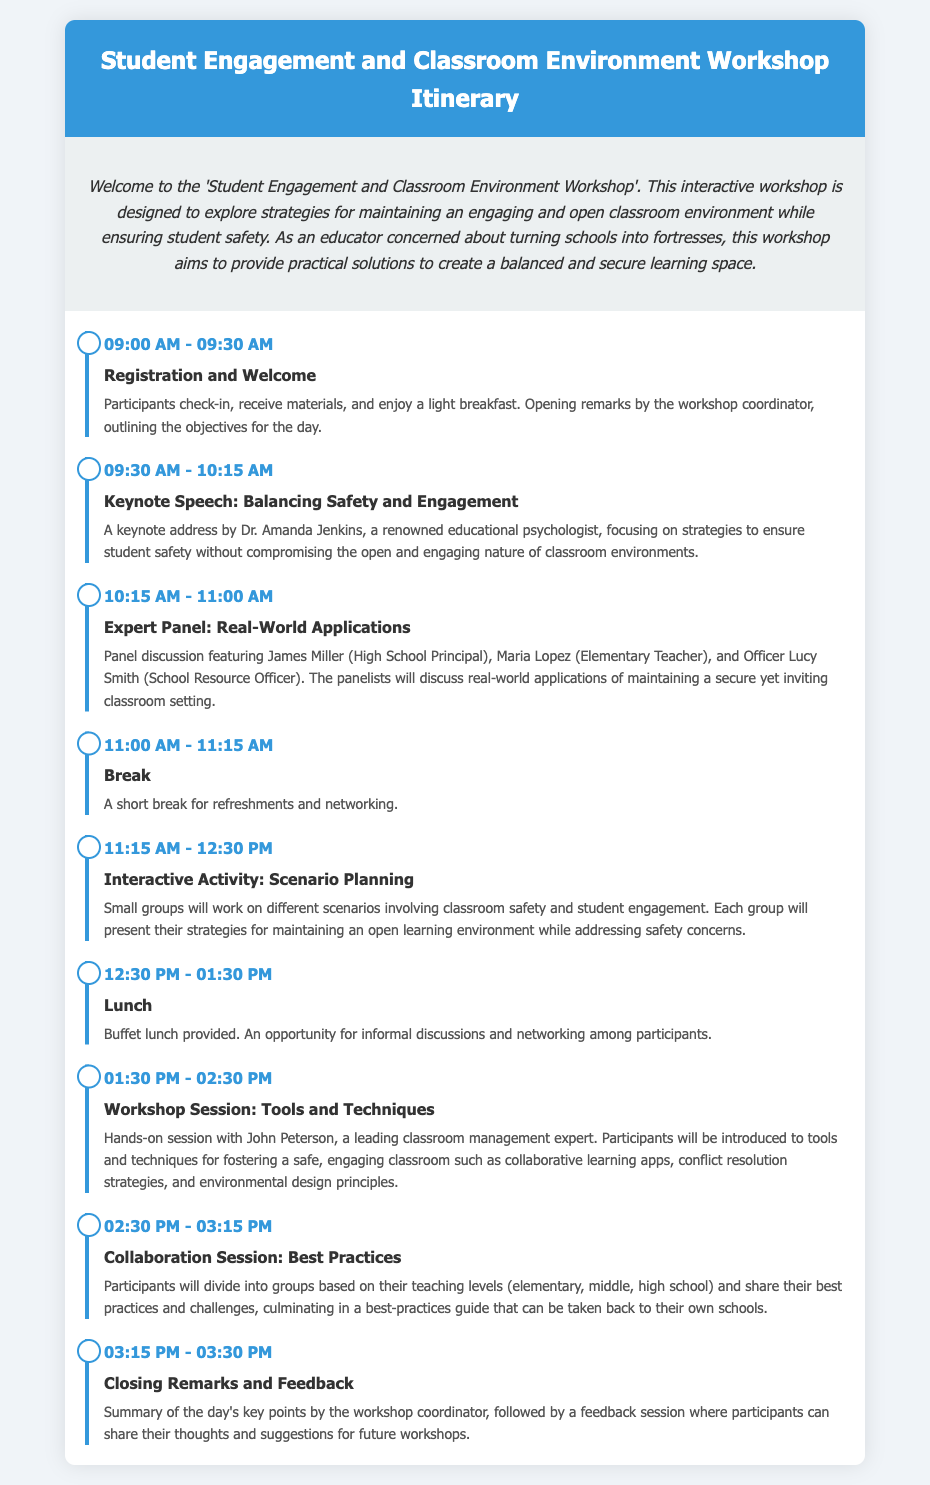what time does the workshop start? The workshop begins with registration at 09:00 AM as indicated in the itinerary.
Answer: 09:00 AM who is the keynote speaker? The keynote speaker is Dr. Amanda Jenkins, mentioned in the schedule.
Answer: Dr. Amanda Jenkins how long is the break during the workshop? The break is specified in the document as lasting for 15 minutes between events, from 11:00 AM to 11:15 AM.
Answer: 15 minutes what activity takes place at 11:15 AM? The activity scheduled at 11:15 AM is named "Interactive Activity: Scenario Planning" as per the itinerary.
Answer: Interactive Activity: Scenario Planning how many expert panelists are featured in the event? The expert panel section lists three panelists participating in the discussion about classroom safety and engagement.
Answer: Three what is the purpose of the collaboration session? The collaboration session aims for participants to share best practices and challenges, creating a guide for their own schools.
Answer: To share best practices who leads the workshop session on tools and techniques? The workshop session is led by John Peterson, a recognized expert in classroom management, as mentioned.
Answer: John Peterson which meal is provided during the workshop schedule? The document specifies that a buffet lunch is provided for participants.
Answer: Buffet lunch what is the final activity of the workshop? The final activity is "Closing Remarks and Feedback," summarizing the day's points and gathering participant feedback.
Answer: Closing Remarks and Feedback 